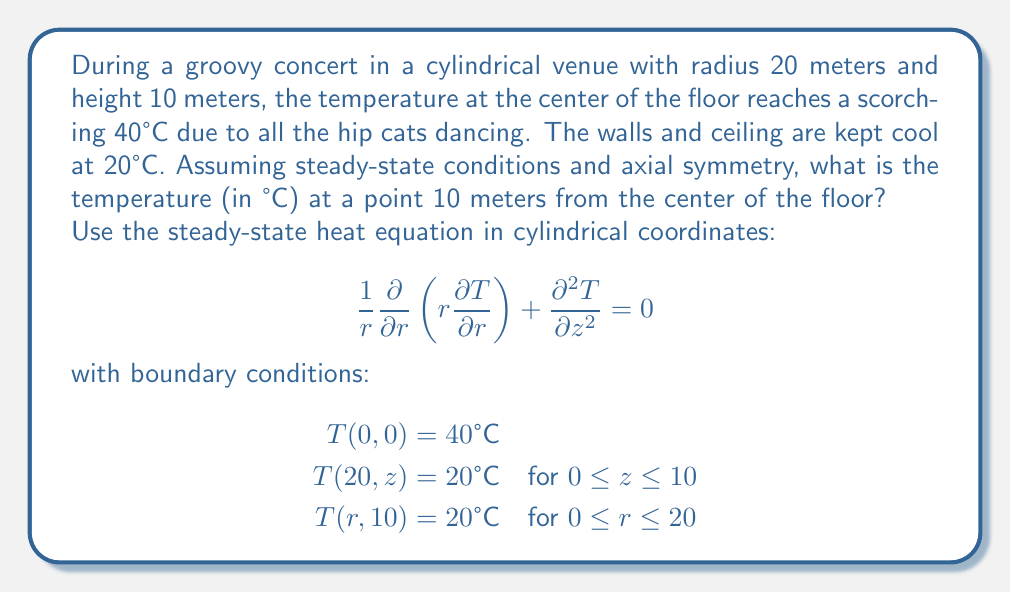Solve this math problem. Alright, cool cats, let's break this down step by step:

1) Given the axial symmetry and steady-state conditions, we can simplify our heat equation to:

   $$\frac{1}{r}\frac{d}{dr}\left(r\frac{dT}{dr}\right) = 0$$

2) Integrating this equation once:

   $$r\frac{dT}{dr} = C_1$$

3) Integrating again:

   $$T(r) = C_1 \ln(r) + C_2$$

4) Now, let's use our boundary conditions to find $C_1$ and $C_2$:
   
   At $r = 20$, $T = 20°C$:
   $$20 = C_1 \ln(20) + C_2$$

   At $r = 0$, $T = 40°C$:
   $$40 = C_2$$ (since $\ln(0)$ is undefined, $C_1$ must be zero for the solution to be valid at $r=0$)

5) Substituting $C_2 = 40$ into the equation from step 4:

   $$20 = C_1 \ln(20) + 40$$
   $$C_1 = \frac{20 - 40}{\ln(20)} \approx -6.8$$

6) Our temperature distribution is thus:

   $$T(r) = -6.8 \ln(r) + 40$$

7) To find the temperature at 10 meters from the center:

   $$T(10) = -6.8 \ln(10) + 40 \approx 24.3°C$$

And there you have it, as smooth as a drum solo!
Answer: 24.3°C 